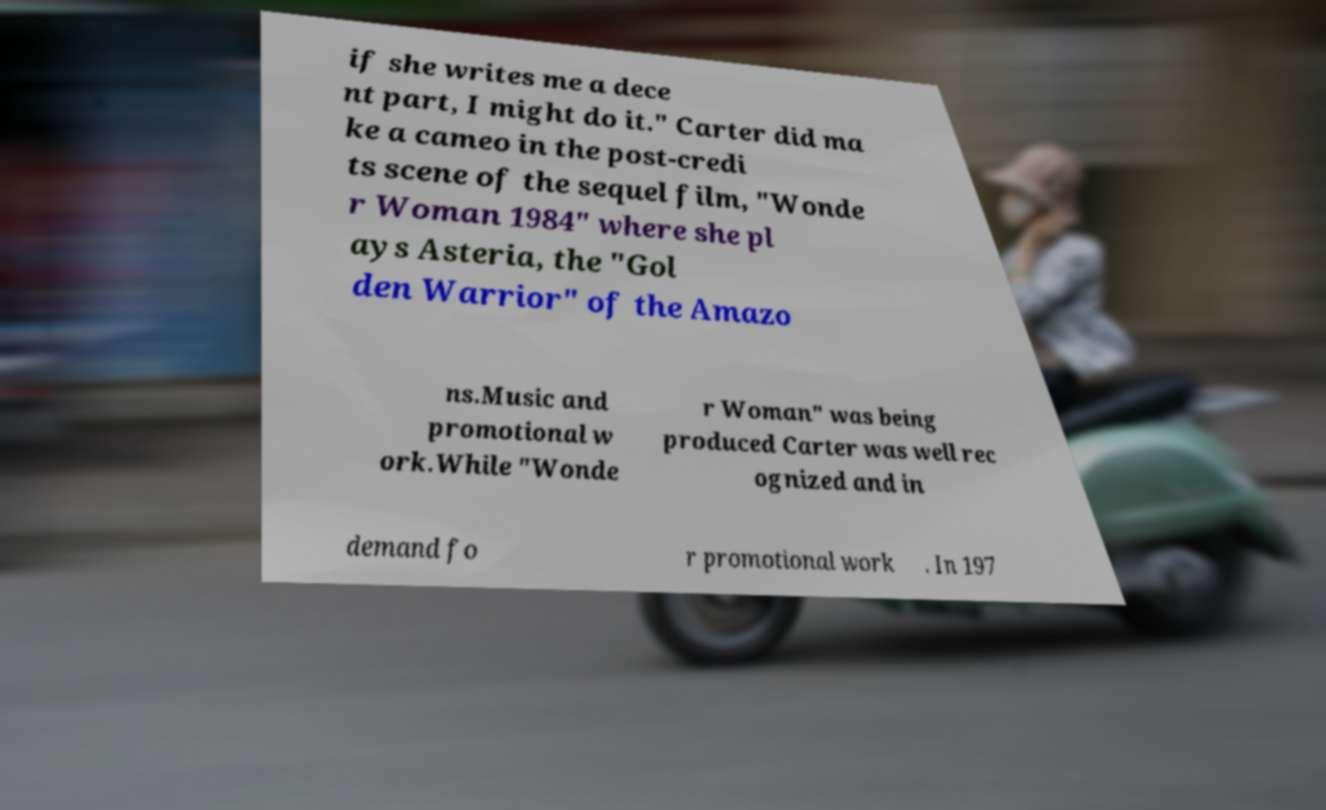Please identify and transcribe the text found in this image. if she writes me a dece nt part, I might do it." Carter did ma ke a cameo in the post-credi ts scene of the sequel film, "Wonde r Woman 1984" where she pl ays Asteria, the "Gol den Warrior" of the Amazo ns.Music and promotional w ork.While "Wonde r Woman" was being produced Carter was well rec ognized and in demand fo r promotional work . In 197 